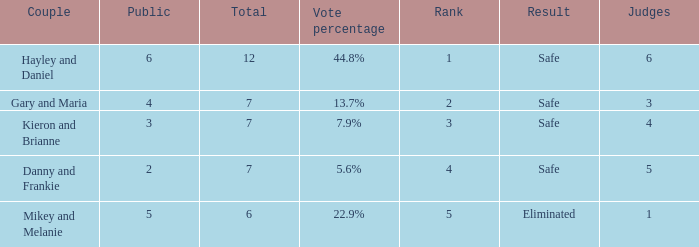How many public is there for the couple that got eliminated? 5.0. Can you parse all the data within this table? {'header': ['Couple', 'Public', 'Total', 'Vote percentage', 'Rank', 'Result', 'Judges'], 'rows': [['Hayley and Daniel', '6', '12', '44.8%', '1', 'Safe', '6'], ['Gary and Maria', '4', '7', '13.7%', '2', 'Safe', '3'], ['Kieron and Brianne', '3', '7', '7.9%', '3', 'Safe', '4'], ['Danny and Frankie', '2', '7', '5.6%', '4', 'Safe', '5'], ['Mikey and Melanie', '5', '6', '22.9%', '5', 'Eliminated', '1']]} 